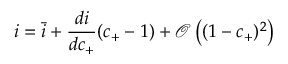<formula> <loc_0><loc_0><loc_500><loc_500>i = \bar { i } + \frac { d i } { d c _ { + } } ( c _ { + } - 1 ) + \mathcal { O } \left ( ( 1 - c _ { + } ) ^ { 2 } \right )</formula> 